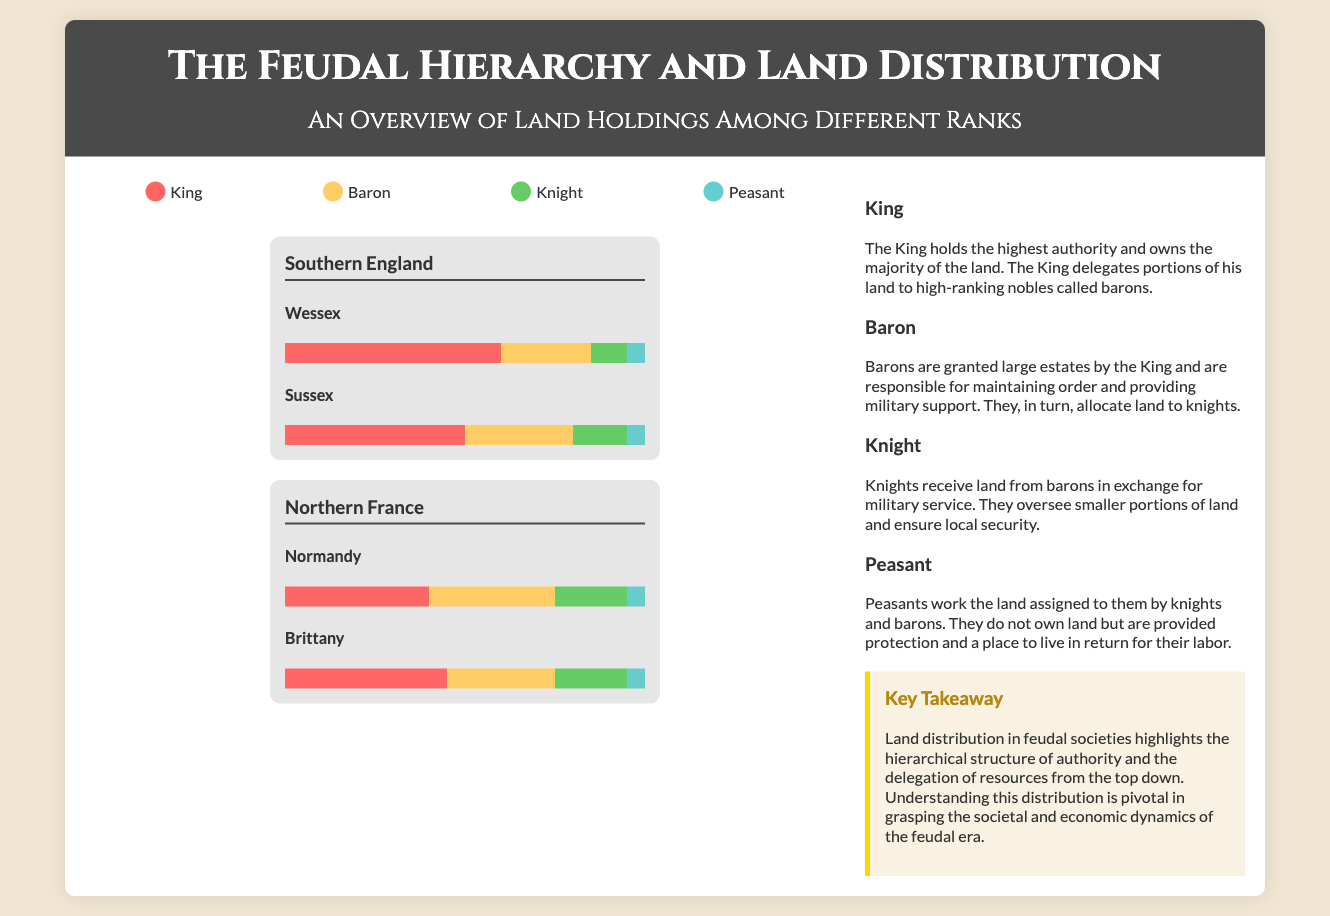What color represents the King? The legend in the infographic shows that the color red (#FF6666) represents the King.
Answer: Red What percentage of land does the Knight hold in Sussex? According to the distribution in Sussex, the Knight holds 15% of the land.
Answer: 15% How many sub-regions are included under Southern England? The infographic lists two sub-regions under Southern England: Wessex and Sussex.
Answer: Two What role do Barons play in the feudal hierarchy? The description for Barons states they are responsible for maintaining order and providing military support.
Answer: Maintain order What is the total percentage of land held by Peasants in Northern France (both Normandy and Brittany)? In Normandy, Peasants hold 5% and in Brittany they also hold 5%, totaling 10%.
Answer: 10% Which region has the highest land percentage owned by Kings? Southern England shows a higher land percentage owned by Kings than Northern France.
Answer: Southern England What is the main takeaway presented in the callout section? The key takeaway emphasizes understanding land distribution as pivotal to grasping societal and economic dynamics.
Answer: Hierarchical structure How much land do Barons control in both regions of Southern England? In Wessex, Barons control 25% and in Sussex they control 30%, totaling 55%.
Answer: 55% 